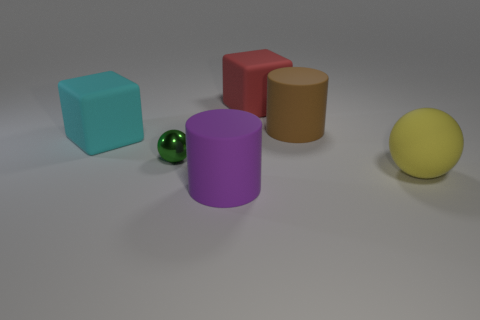Subtract all yellow balls. How many balls are left? 1 Add 2 gray cylinders. How many objects exist? 8 Add 5 small rubber things. How many small rubber things exist? 5 Subtract 0 purple balls. How many objects are left? 6 Subtract all red cylinders. Subtract all purple blocks. How many cylinders are left? 2 Subtract all small brown cylinders. Subtract all cylinders. How many objects are left? 4 Add 1 red things. How many red things are left? 2 